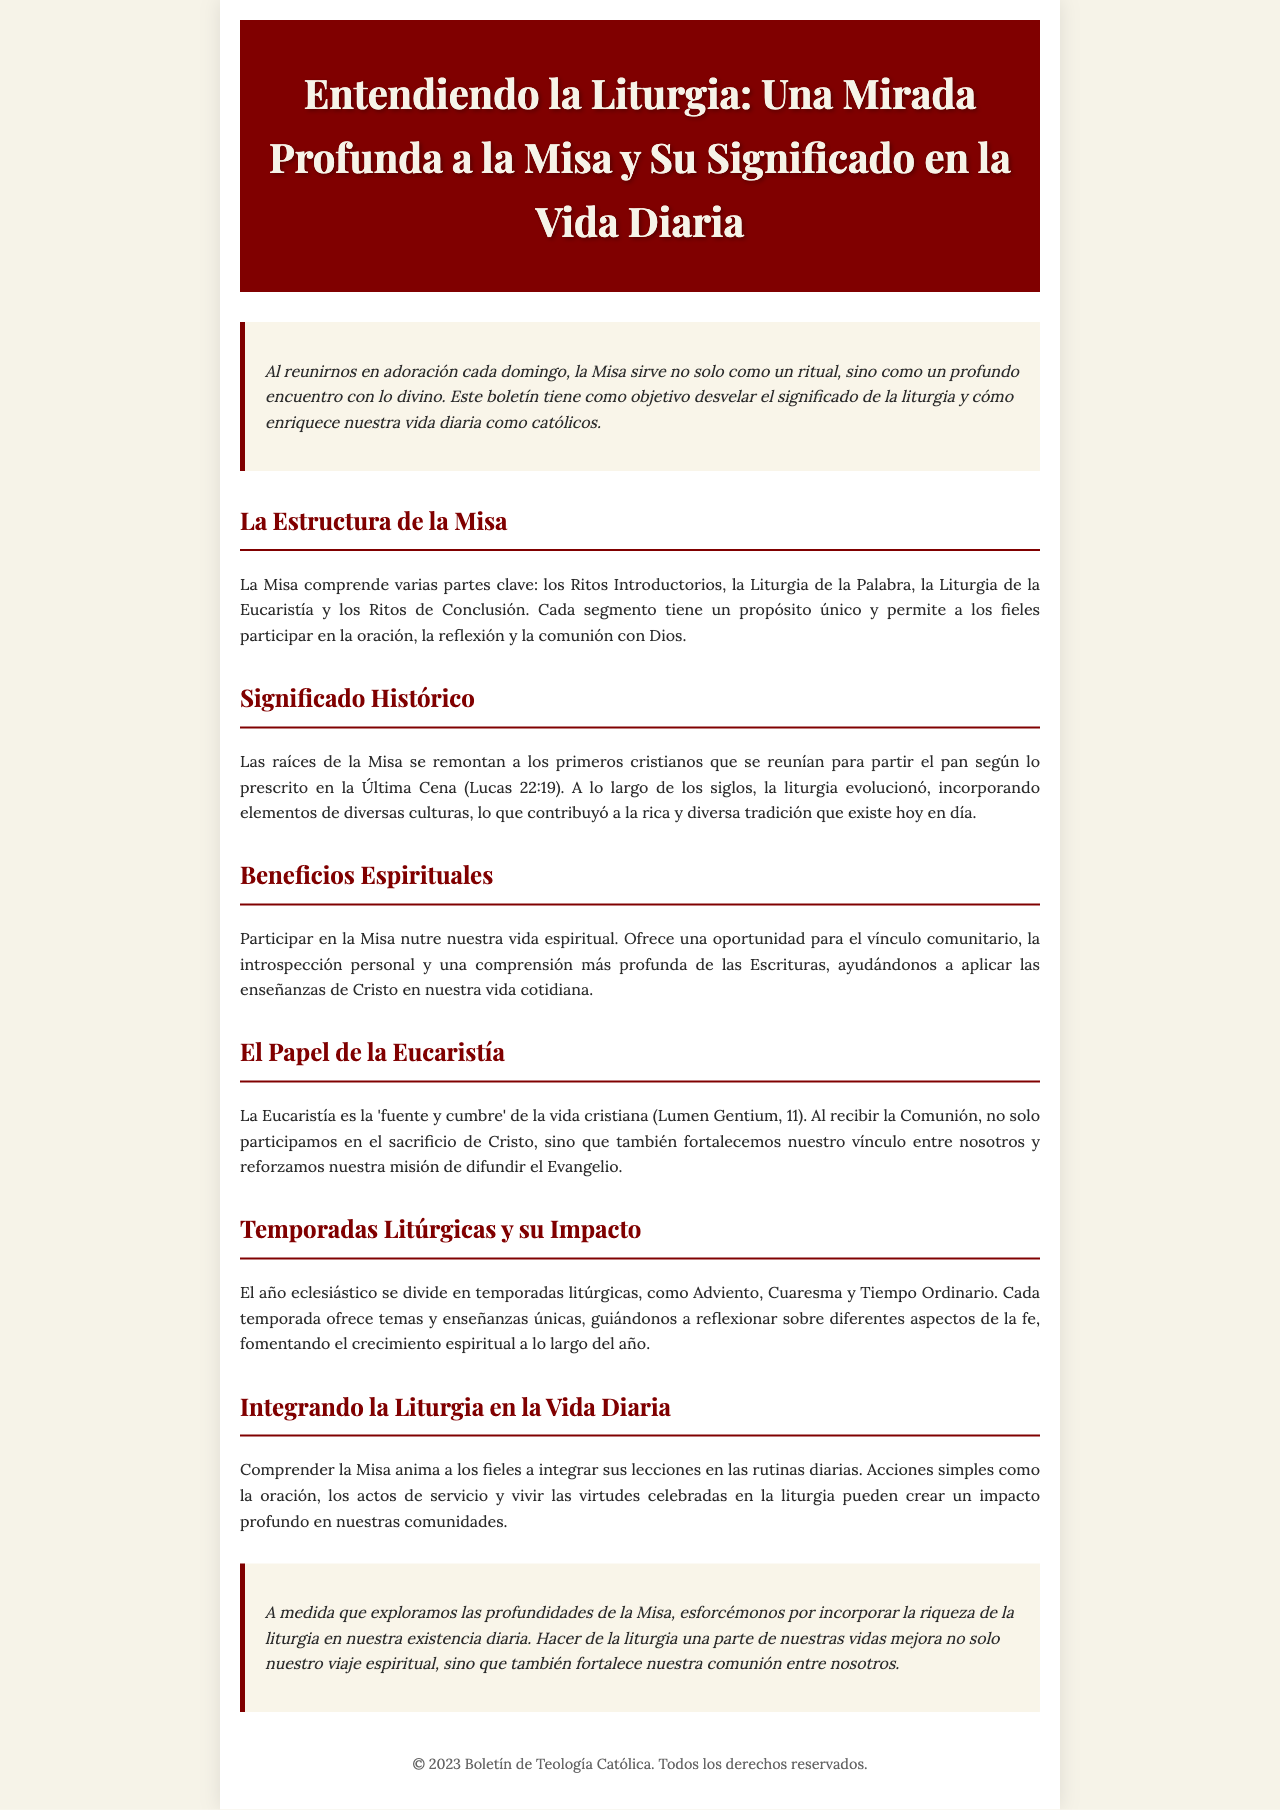¿Qué comprende la Misa? La Misa comprende varias partes clave según el documento: los Ritos Introductorios, la Liturgia de la Palabra, la Liturgia de la Eucaristía y los Ritos de Conclusión.
Answer: los Ritos Introductorios, la Liturgia de la Palabra, la Liturgia de la Eucaristía y los Ritos de Conclusión ¿Cuál es la raíz histórica de la Misa? La raíz histórica de la Misa se remonta a los primeros cristianos que se reunían para partir el pan según lo prescrito en la Última Cena.
Answer: Última Cena ¿Qué nutre nuestra vida espiritual según el boletín? Participar en la Misa nutre nuestra vida espiritual y ofrece una oportunidad para el vínculo comunitario.
Answer: vínculo comunitario ¿Qué es la Eucaristía en el contexto del documento? En el contexto del documento, la Eucaristía es descrita como la 'fuente y cumbre' de la vida cristiana.
Answer: 'fuente y cumbre' ¿Cómo se divide el año eclesiástico? El año eclesiástico se divide en temporadas litúrgicas como Adviento, Cuaresma y Tiempo Ordinario.
Answer: Adviento, Cuaresma y Tiempo Ordinario ¿Qué se alienta a hacer con las lecciones de la Misa? Se alienta a integrar las lecciones de la Misa en las rutinas diarias de los fieles.
Answer: integrar las lecciones en las rutinas diarias ¿Por qué es importante la liturgia en la vida diaria? La liturgia mejora nuestro viaje espiritual y fortalece nuestra comunión entre nosotros.
Answer: mejora nuestro viaje espiritual y fortalece nuestra comunión ¿Cuál es el objetivo principal del boletín? El objetivo principal del boletín es desvelar el significado de la liturgia y cómo enriquece nuestra vida diaria.
Answer: desvelar el significado de la liturgia y cómo enriquece nuestra vida diaria 